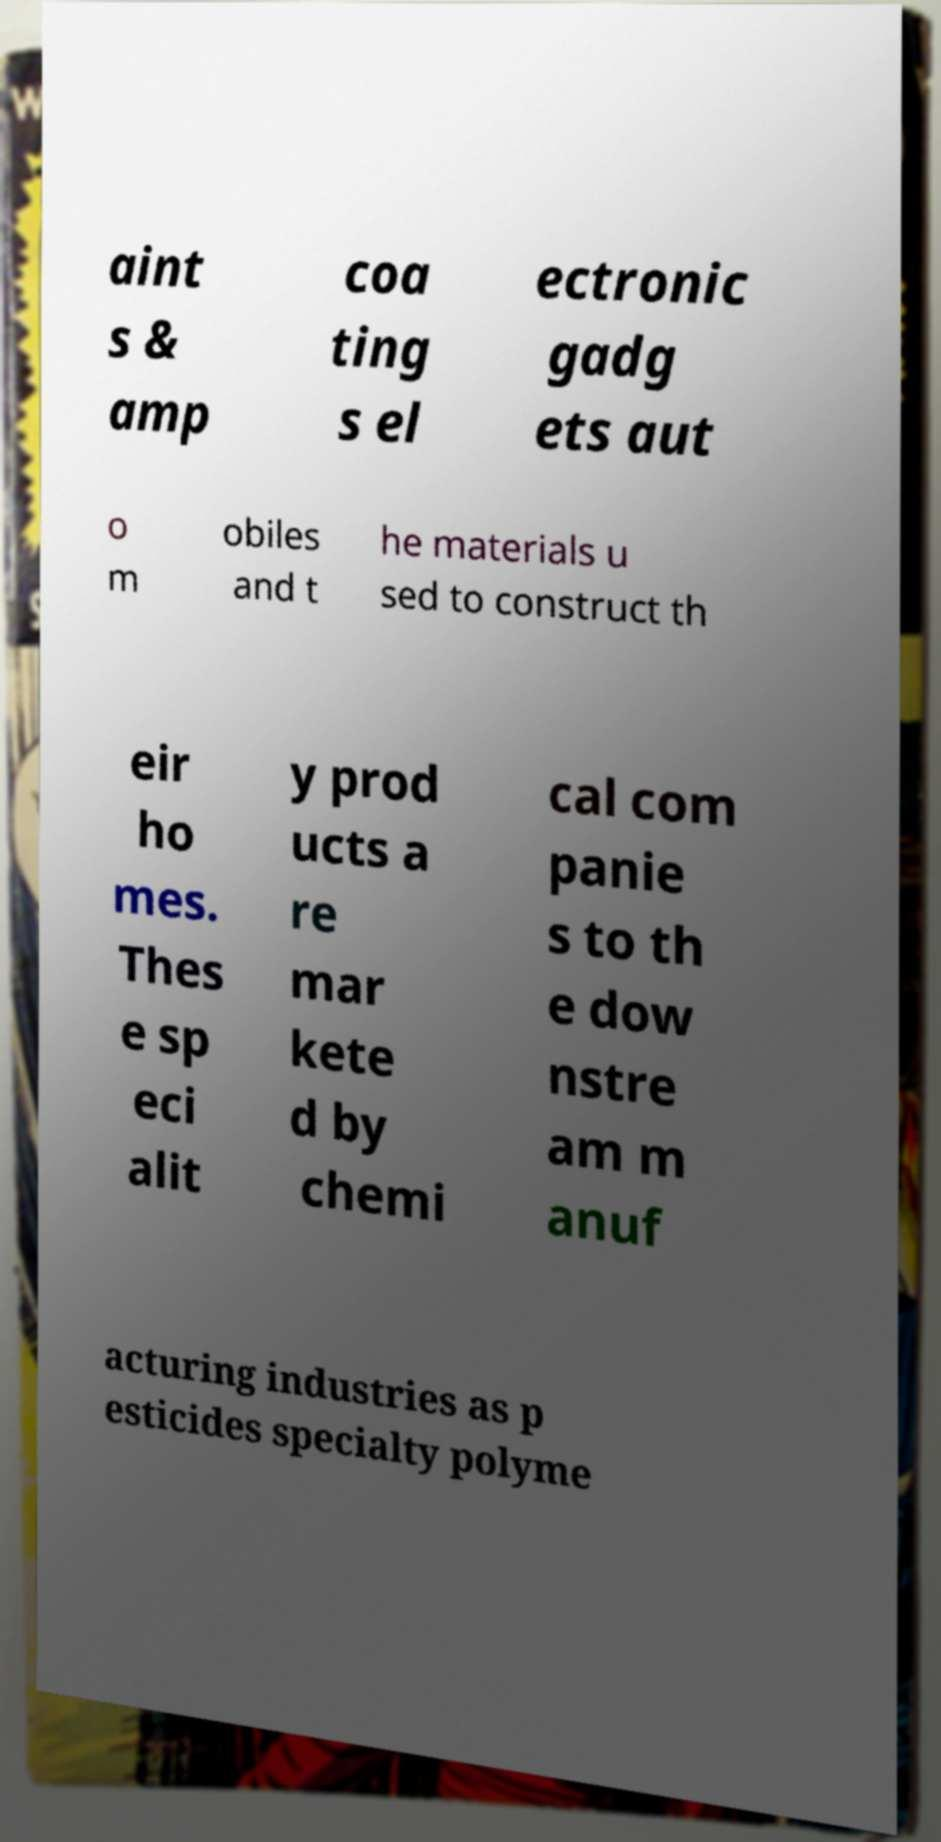Please identify and transcribe the text found in this image. aint s & amp coa ting s el ectronic gadg ets aut o m obiles and t he materials u sed to construct th eir ho mes. Thes e sp eci alit y prod ucts a re mar kete d by chemi cal com panie s to th e dow nstre am m anuf acturing industries as p esticides specialty polyme 